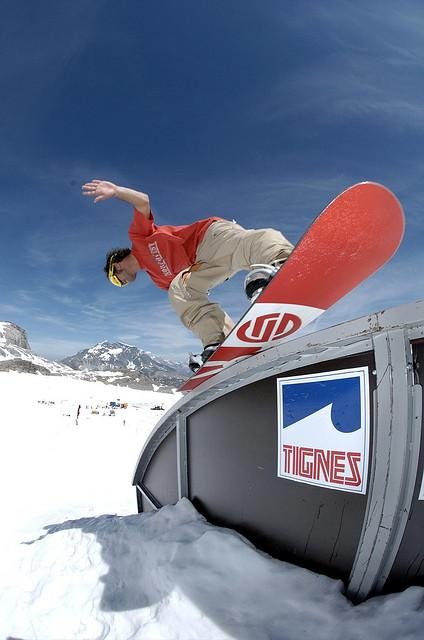What is this type of snowboard trick called? grinding 